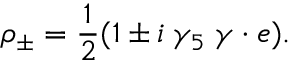Convert formula to latex. <formula><loc_0><loc_0><loc_500><loc_500>\rho _ { \pm } = \frac { 1 } { 2 } ( 1 \pm i \, \gamma _ { 5 } \, \gamma \cdot e ) .</formula> 